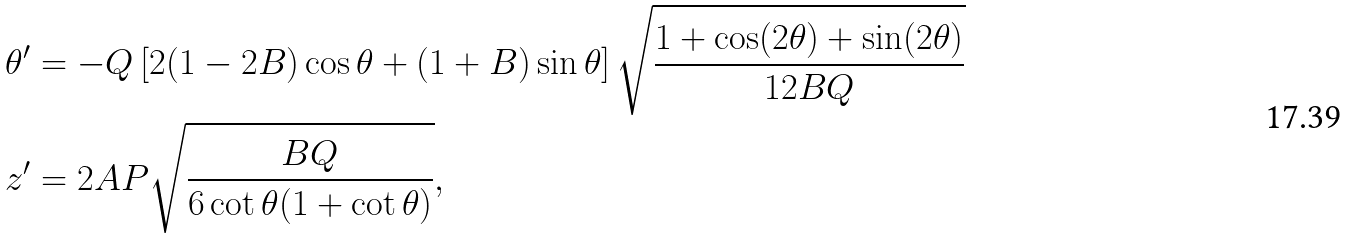<formula> <loc_0><loc_0><loc_500><loc_500>\theta ^ { \prime } & = - Q \left [ 2 ( 1 - 2 B ) \cos \theta + ( 1 + B ) \sin \theta \right ] \sqrt { \frac { 1 + \cos ( 2 \theta ) + \sin ( 2 \theta ) } { 1 2 B Q } } \\ z ^ { \prime } & = 2 A P \sqrt { \frac { B Q } { 6 \cot \theta ( 1 + \cot \theta ) } } ,</formula> 